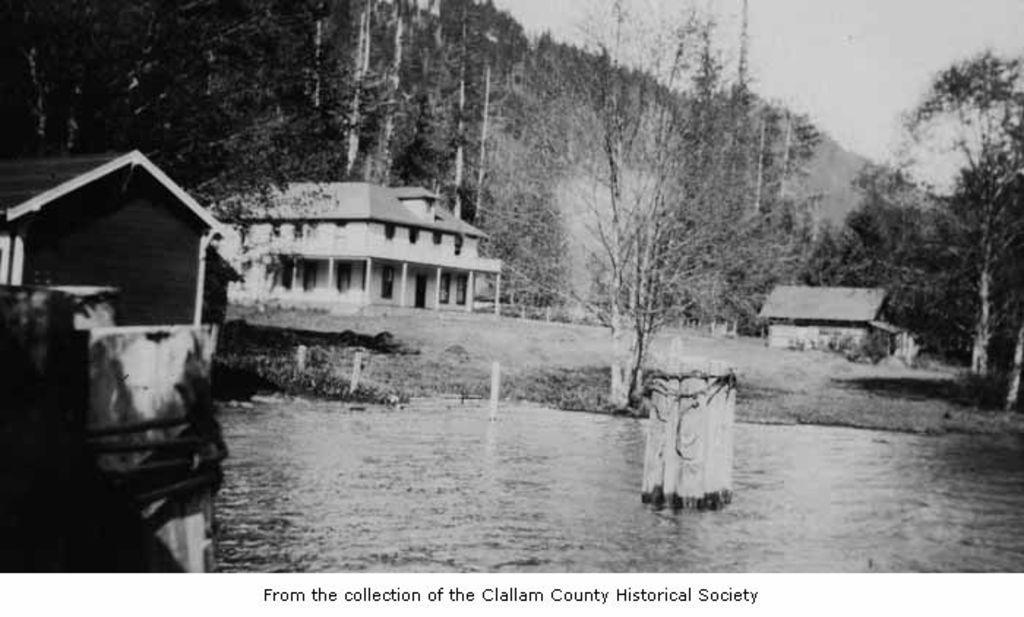How would you summarize this image in a sentence or two? This picture consists of a poster in the image, where there are houses, trees, and water in the image. 